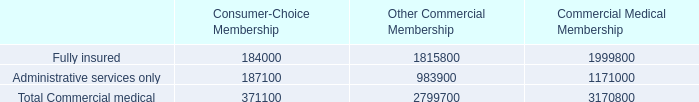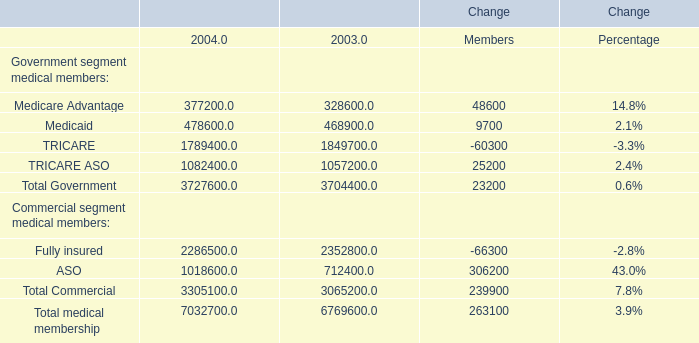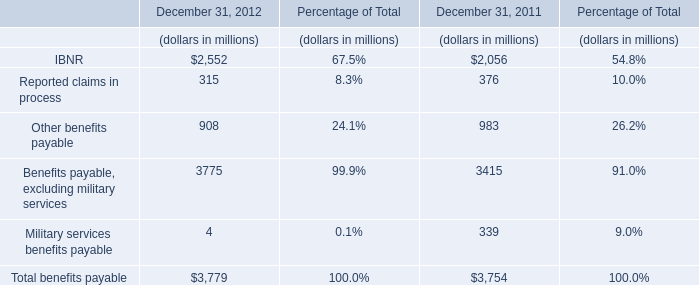What is the average amount of Fully insured of Commercial Medical Membership, and Medicaid of Change 2004 ? 
Computations: ((1999800.0 + 478600.0) / 2)
Answer: 1239200.0. 